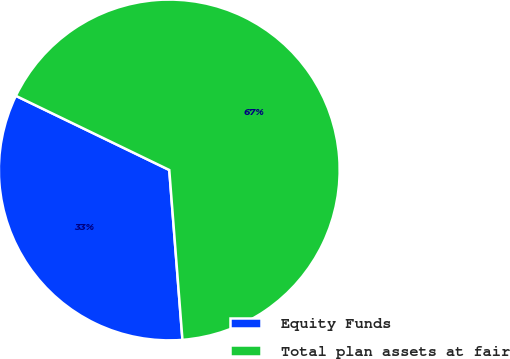<chart> <loc_0><loc_0><loc_500><loc_500><pie_chart><fcel>Equity Funds<fcel>Total plan assets at fair<nl><fcel>33.4%<fcel>66.6%<nl></chart> 